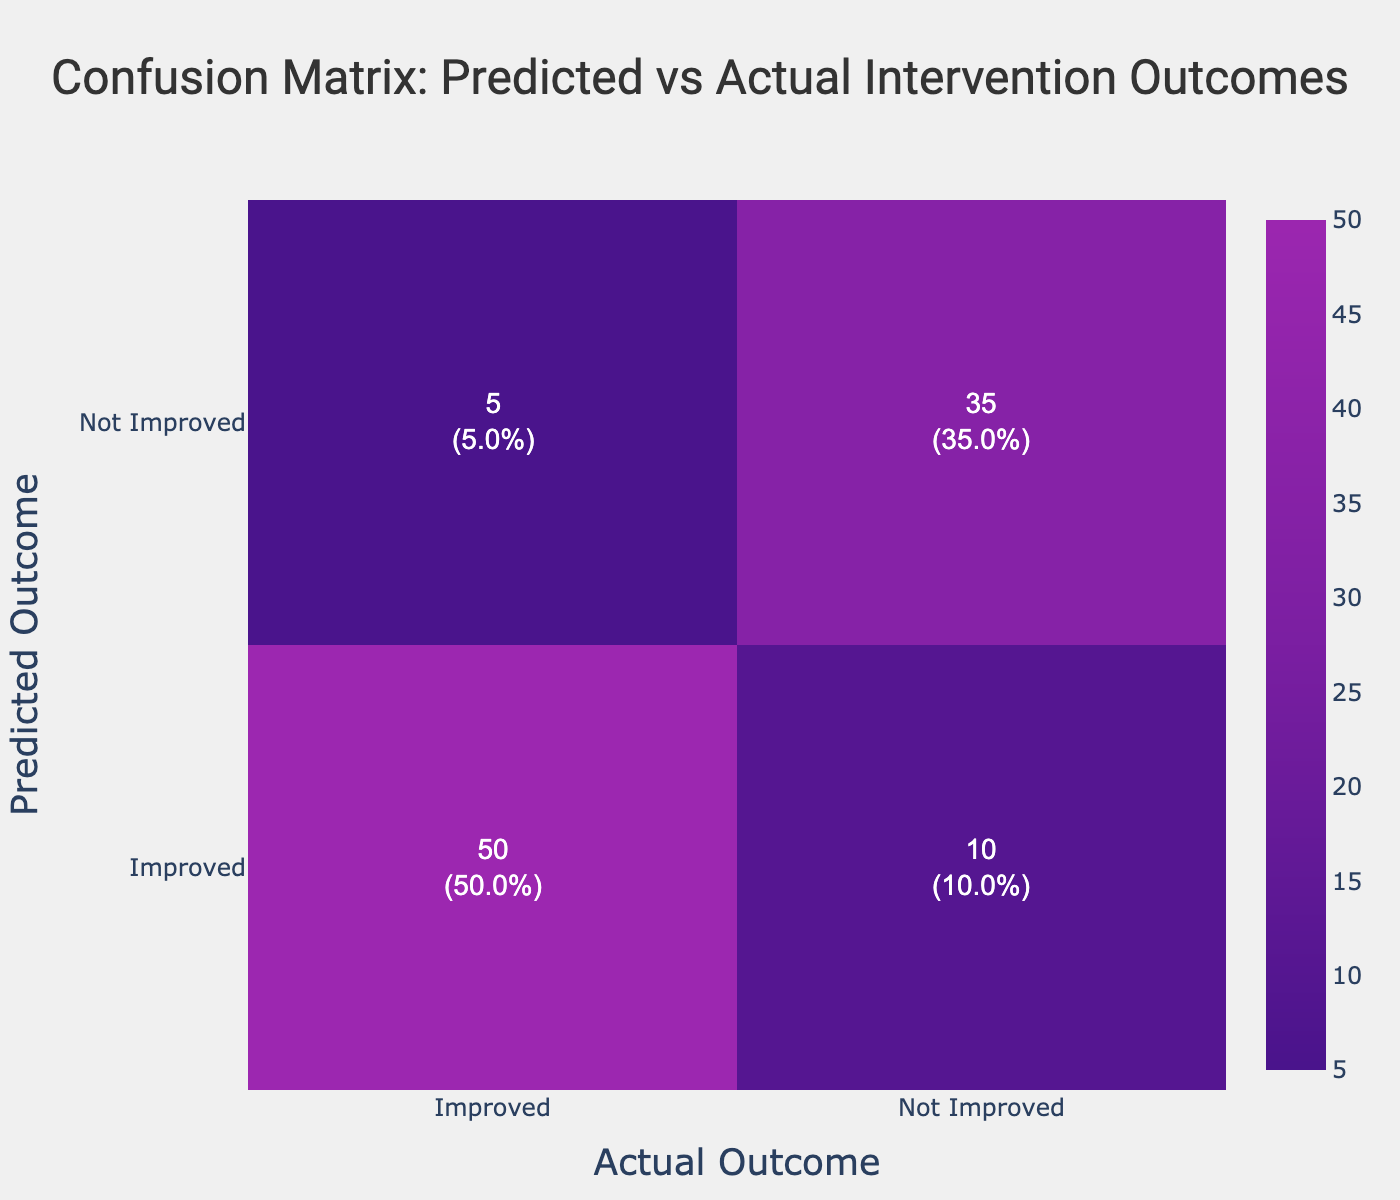What is the count of cases where the predicted outcome was "Improved" and the actual outcome was also "Improved"? Referring to the table, the count for the combination of "Improved" predicted and "Improved" actual is directly provided as 50.
Answer: 50 What is the total number of cases where the actual outcome was "Not Improved"? The actual outcome being "Not Improved" occurs in two scenarios: predicted as "Improved" (10 cases) and predicted as "Not Improved" (35 cases). Summing these gives 10 + 35 = 45.
Answer: 45 Is the number of times the predicted outcome was "Not Improved" higher than the number of times the actual outcome was "Improved"? The count for "Not Improved" predicted is 35 + 5 = 40, while the count for "Improved" actual is 50. Since 40 is less than 50, the answer is no.
Answer: No What is the percentage of cases where the predicted outcome was "Improved" and the actual outcome was "Not Improved"? There are 10 such cases. The total number of cases is 50 + 10 + 5 + 35 = 100. The percentage is (10 / 100) * 100 = 10%.
Answer: 10% How many cases were falsely predicted as "Not Improved" when the actual outcome was "Improved"? This occurs when the predicted outcome is "Not Improved" and the actual outcome is "Improved", which corresponds to 5 cases according to the table.
Answer: 5 What is the average count of cases across all predicted outcomes? To find the average, sum all counts: 50 + 10 + 5 + 35 = 100. There are 4 categories, so the average is 100 / 4 = 25.
Answer: 25 How many total cases were correctly predicted? The correctly predicted cases are those where the predicted outcome matches the actual outcome. This includes "Improved" to "Improved" (50) and "Not Improved" to "Not Improved" (35), adding to 50 + 35 = 85.
Answer: 85 What is the difference in count between the predicted outcome of "Improved" and the actual outcome of "Not Improved"? The predicted outcome of "Improved" resulted in 10 cases where the actual outcome was "Not Improved". The actual outcome of "Not Improved" are 45 cases. The difference is 45 - 10 = 35.
Answer: 35 Is it true that more than half of the total cases experienced an actual outcome of "Not Improved"? The total number of cases is 100 and the count for "Not Improved" is 45. Since 45 is less than 50 (half of 100), the statement is false.
Answer: No 